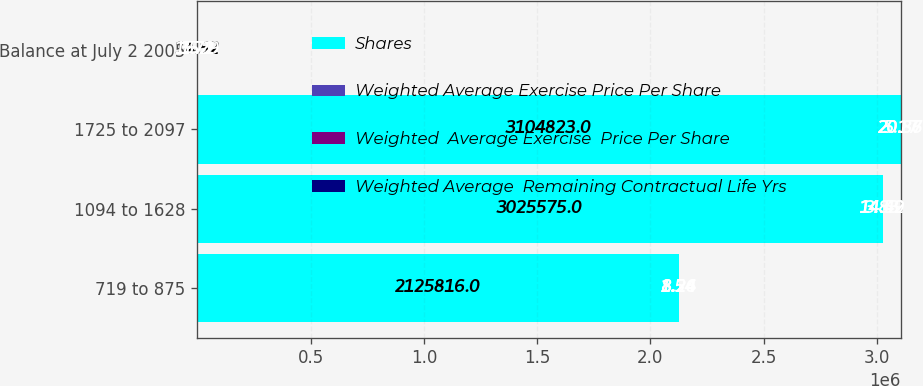<chart> <loc_0><loc_0><loc_500><loc_500><stacked_bar_chart><ecel><fcel>719 to 875<fcel>1094 to 1628<fcel>1725 to 2097<fcel>Balance at July 2 2005<nl><fcel>Shares<fcel>2.12582e+06<fcel>3.02558e+06<fcel>3.10482e+06<fcel>14.52<nl><fcel>Weighted Average Exercise Price Per Share<fcel>8.24<fcel>14.52<fcel>20.86<fcel>15.29<nl><fcel>Weighted  Average Exercise  Price Per Share<fcel>1.54<fcel>3.83<fcel>5.17<fcel>3.71<nl><fcel>Weighted Average  Remaining Contractual Life Yrs<fcel>8.26<fcel>14.49<fcel>20.87<fcel>15.2<nl></chart> 